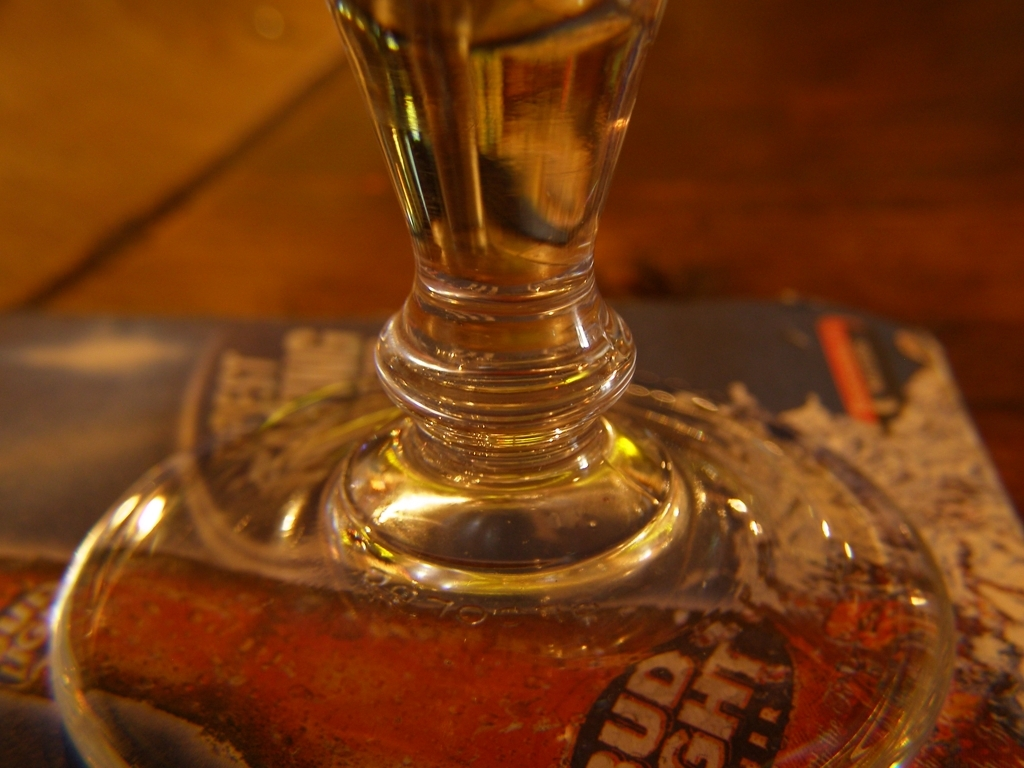What kind of object do we see here, and what might its use be? The object in the image seems to be a stemmed glass, typically used for serving beverages like wine or cocktails. The focus on the stem emphasizes its design and material. Could you describe the atmosphere suggested by the image? The close-up shot, warm tones, and soft focus in the background suggest a cozy and relaxed setting, perhaps an establishment where drinks are served and enjoyed during leisure time. 